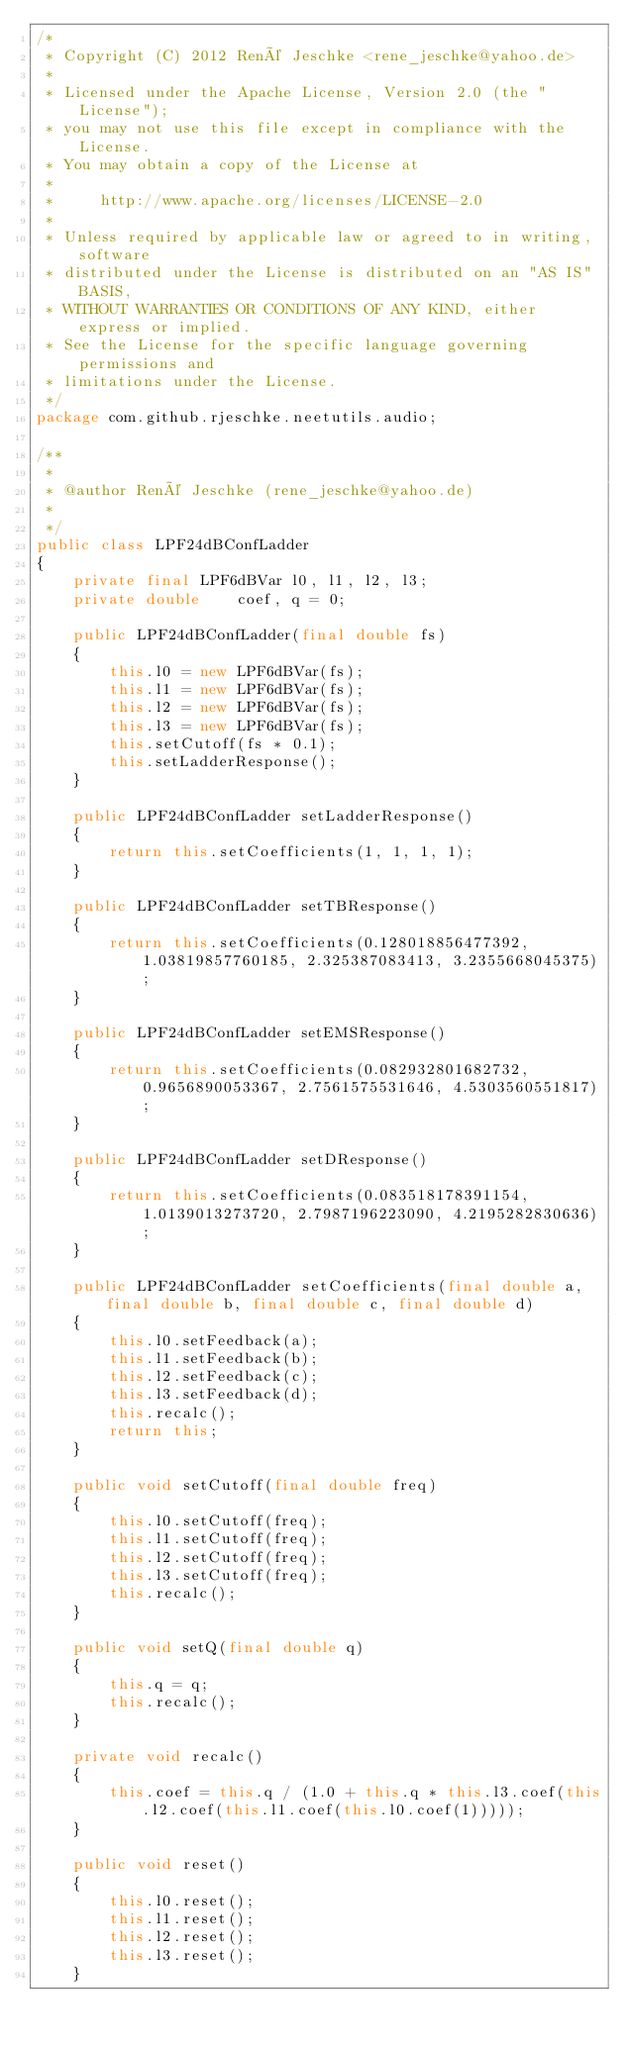Convert code to text. <code><loc_0><loc_0><loc_500><loc_500><_Java_>/*
 * Copyright (C) 2012 René Jeschke <rene_jeschke@yahoo.de>
 *
 * Licensed under the Apache License, Version 2.0 (the "License");
 * you may not use this file except in compliance with the License.
 * You may obtain a copy of the License at
 *
 *     http://www.apache.org/licenses/LICENSE-2.0
 *
 * Unless required by applicable law or agreed to in writing, software
 * distributed under the License is distributed on an "AS IS" BASIS,
 * WITHOUT WARRANTIES OR CONDITIONS OF ANY KIND, either express or implied.
 * See the License for the specific language governing permissions and
 * limitations under the License.
 */
package com.github.rjeschke.neetutils.audio;

/**
 *
 * @author René Jeschke (rene_jeschke@yahoo.de)
 *
 */
public class LPF24dBConfLadder
{
    private final LPF6dBVar l0, l1, l2, l3;
    private double    coef, q = 0;

    public LPF24dBConfLadder(final double fs)
    {
        this.l0 = new LPF6dBVar(fs);
        this.l1 = new LPF6dBVar(fs);
        this.l2 = new LPF6dBVar(fs);
        this.l3 = new LPF6dBVar(fs);
        this.setCutoff(fs * 0.1);
        this.setLadderResponse();
    }

    public LPF24dBConfLadder setLadderResponse()
    {
        return this.setCoefficients(1, 1, 1, 1);
    }

    public LPF24dBConfLadder setTBResponse()
    {
        return this.setCoefficients(0.128018856477392, 1.03819857760185, 2.325387083413, 3.2355668045375);
    }

    public LPF24dBConfLadder setEMSResponse()
    {
        return this.setCoefficients(0.082932801682732, 0.9656890053367, 2.7561575531646, 4.5303560551817);
    }

    public LPF24dBConfLadder setDResponse()
    {
        return this.setCoefficients(0.083518178391154, 1.0139013273720, 2.7987196223090, 4.2195282830636);
    }

    public LPF24dBConfLadder setCoefficients(final double a, final double b, final double c, final double d)
    {
        this.l0.setFeedback(a);
        this.l1.setFeedback(b);
        this.l2.setFeedback(c);
        this.l3.setFeedback(d);
        this.recalc();
        return this;
    }

    public void setCutoff(final double freq)
    {
        this.l0.setCutoff(freq);
        this.l1.setCutoff(freq);
        this.l2.setCutoff(freq);
        this.l3.setCutoff(freq);
        this.recalc();
    }

    public void setQ(final double q)
    {
        this.q = q;
        this.recalc();
    }

    private void recalc()
    {
        this.coef = this.q / (1.0 + this.q * this.l3.coef(this.l2.coef(this.l1.coef(this.l0.coef(1)))));
    }

    public void reset()
    {
        this.l0.reset();
        this.l1.reset();
        this.l2.reset();
        this.l3.reset();
    }
</code> 